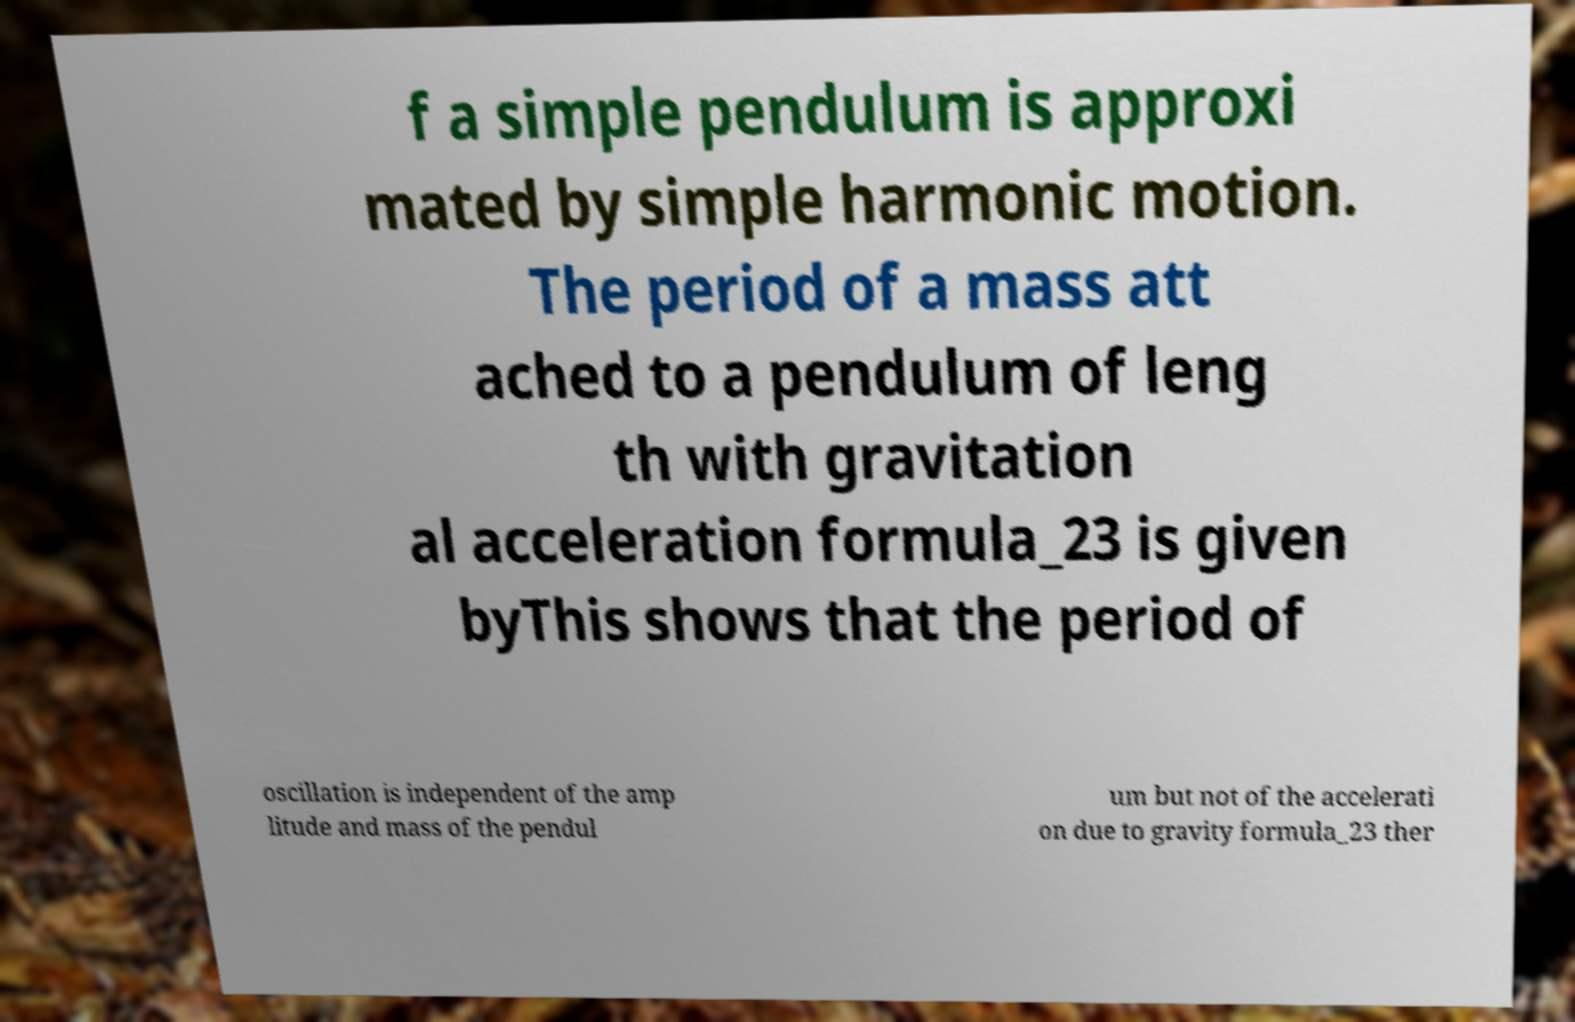Could you assist in decoding the text presented in this image and type it out clearly? f a simple pendulum is approxi mated by simple harmonic motion. The period of a mass att ached to a pendulum of leng th with gravitation al acceleration formula_23 is given byThis shows that the period of oscillation is independent of the amp litude and mass of the pendul um but not of the accelerati on due to gravity formula_23 ther 